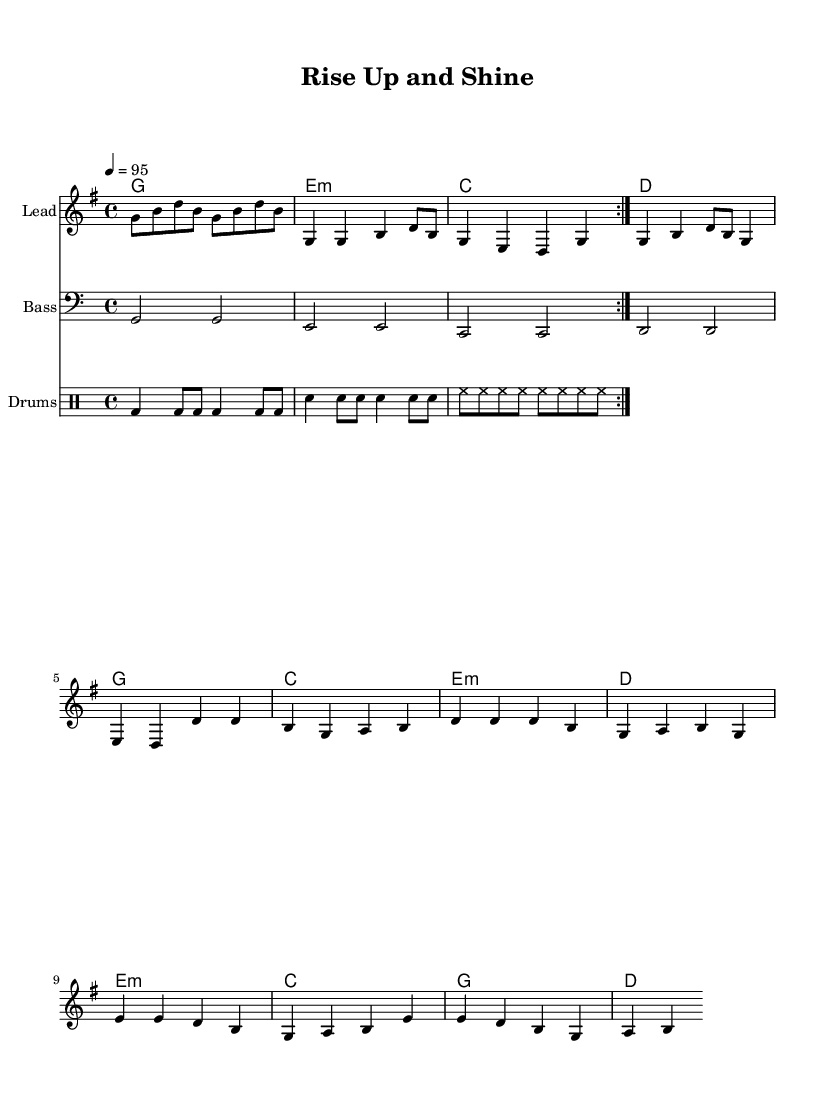What is the key signature of this music? The key signature shown at the beginning of the score indicates the key of G major, which has one sharp (F#).
Answer: G major What is the time signature of this music? The time signature is notated at the beginning of the score, indicating that there are 4 beats per measure.
Answer: 4/4 What is the tempo marking of this music? The tempo marking indicates the speed of the music, showing that it should be played at a metronome marking of 95 beats per minute.
Answer: 95 How many measures are in the verse section? By counting the number of measures indicated in the 'melody' part corresponding to the verse lyrics, we find there are 4 measures.
Answer: 4 What type of harmony is used in the bridge? The harmony notated in the bridge section shows the use of a minor chord (E minor), which is represented with a lowercase 'm'.
Answer: E minor What rhythmic elements are typically found in Hip Hop music based on this score? The rhythmic patterns from the drum section, such as the bass drum and snare patterns, highlight the typical syncopated beats that are characteristic of Hip Hop music.
Answer: Syncopated beats What is the main theme expressed in the chorus lyrics? The chorus lyrics express a theme of celebration and personal growth, as noted by phrases emphasizing triumph and progress.
Answer: Celebration and personal growth 